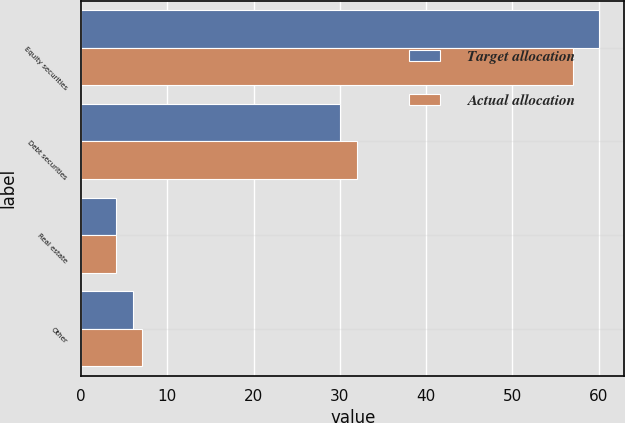Convert chart. <chart><loc_0><loc_0><loc_500><loc_500><stacked_bar_chart><ecel><fcel>Equity securities<fcel>Debt securities<fcel>Real estate<fcel>Other<nl><fcel>Target allocation<fcel>60<fcel>30<fcel>4<fcel>6<nl><fcel>Actual allocation<fcel>57<fcel>32<fcel>4<fcel>7<nl></chart> 